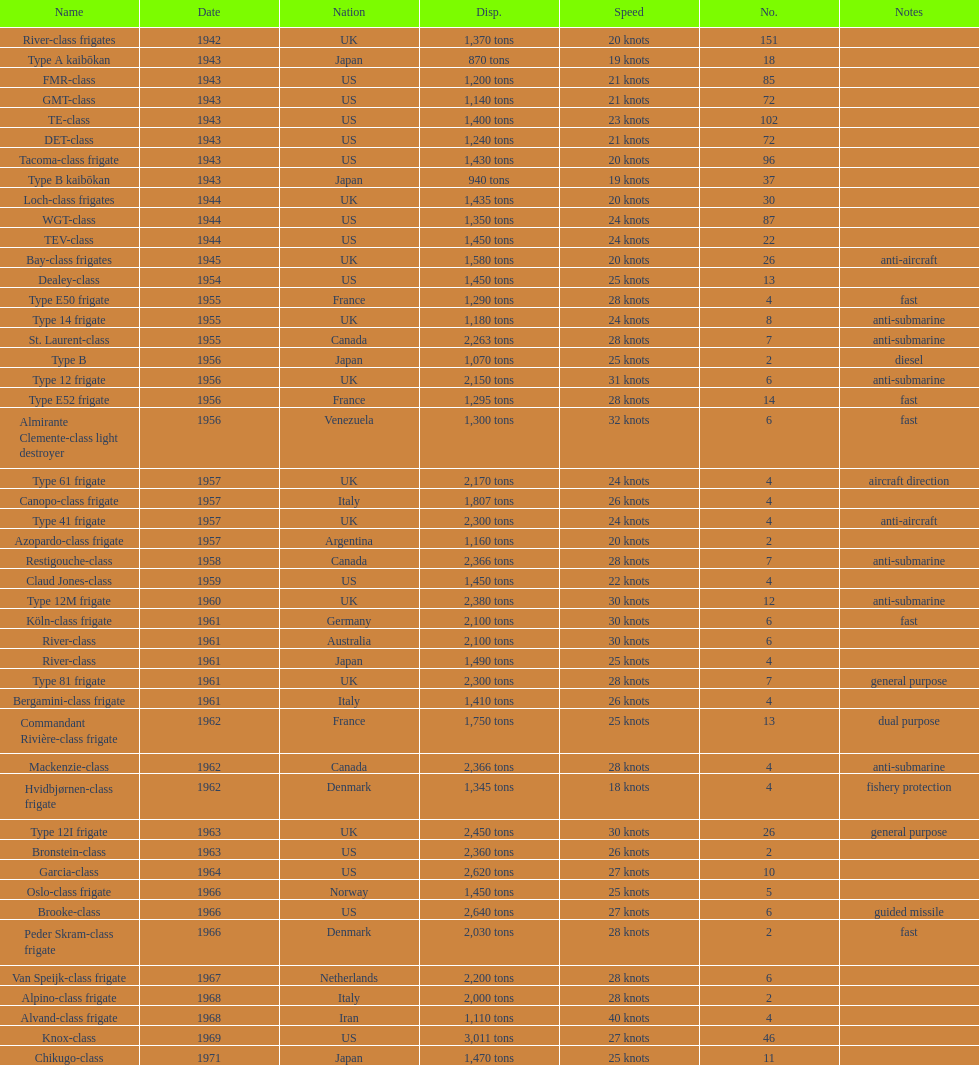What is the top speed? 40 knots. 